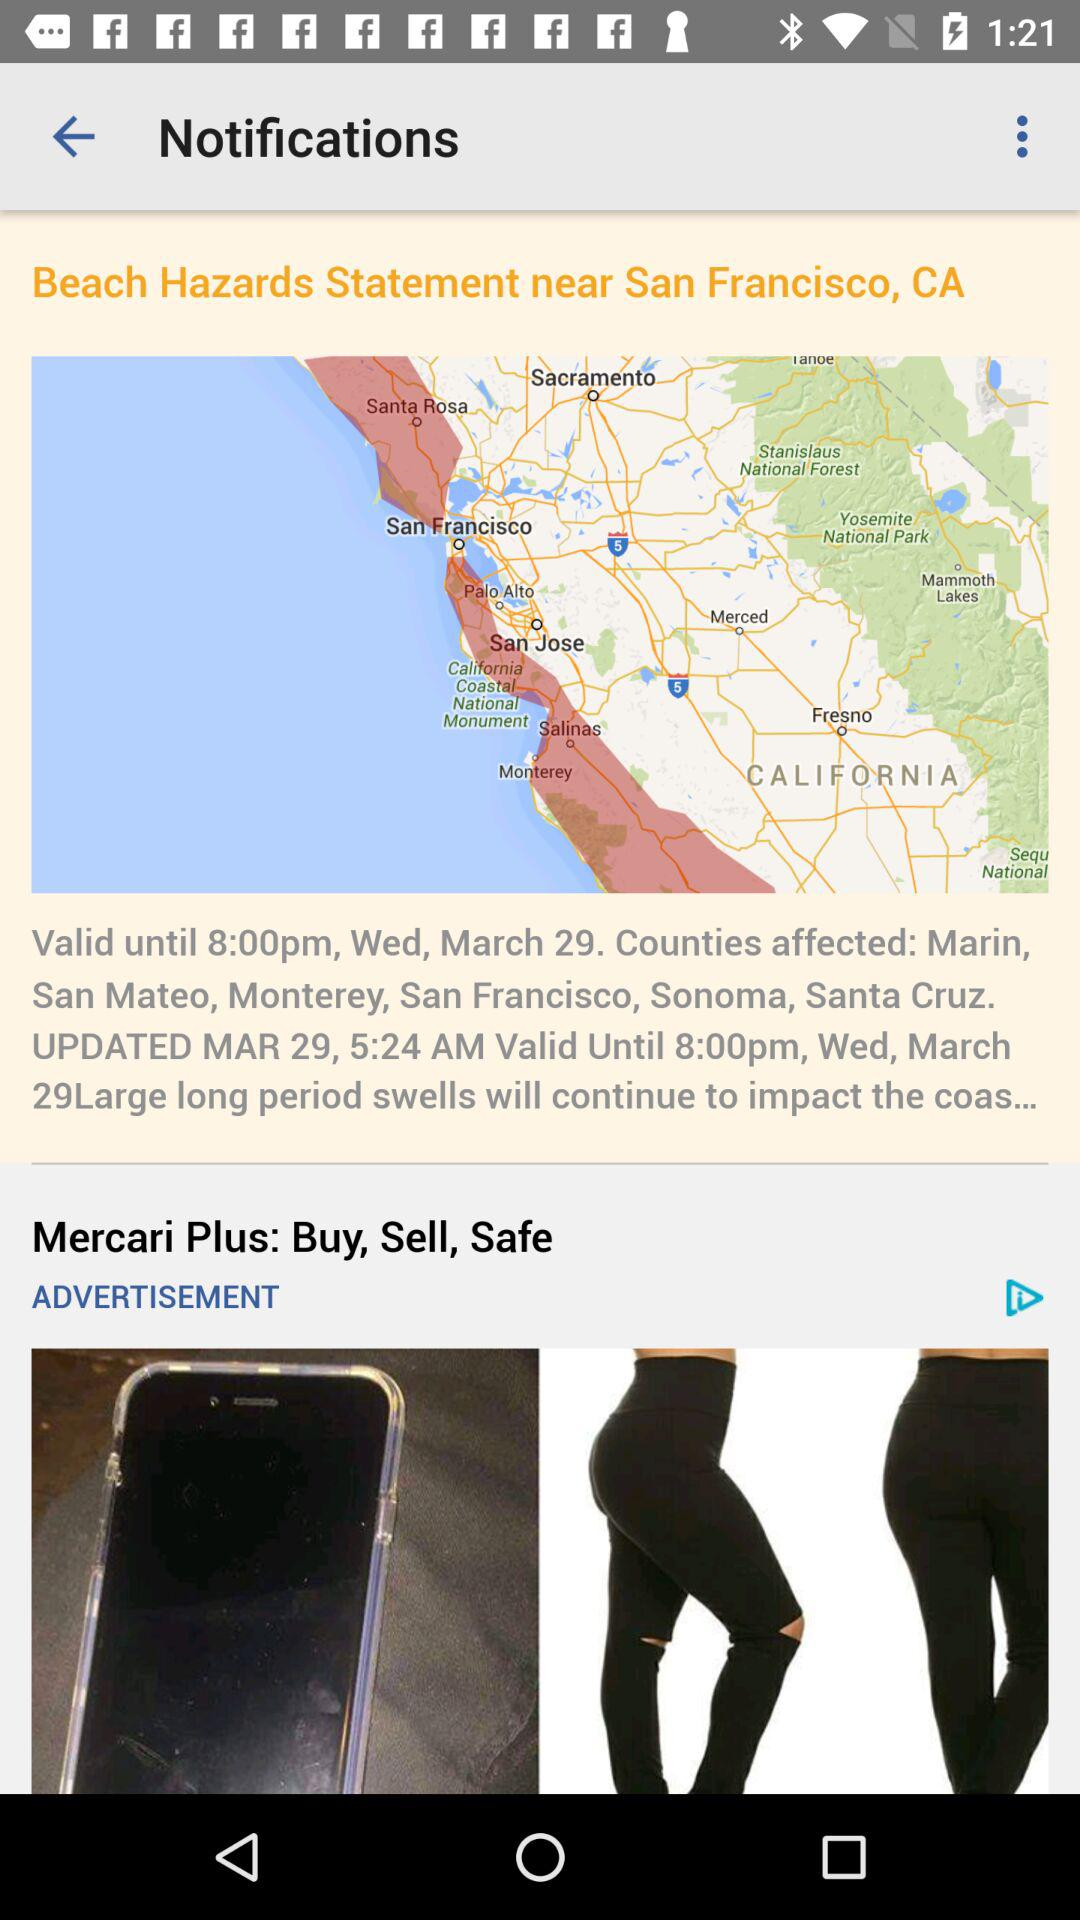What is the time? The times are 8:00 p.m. and 5:24 a.m. 